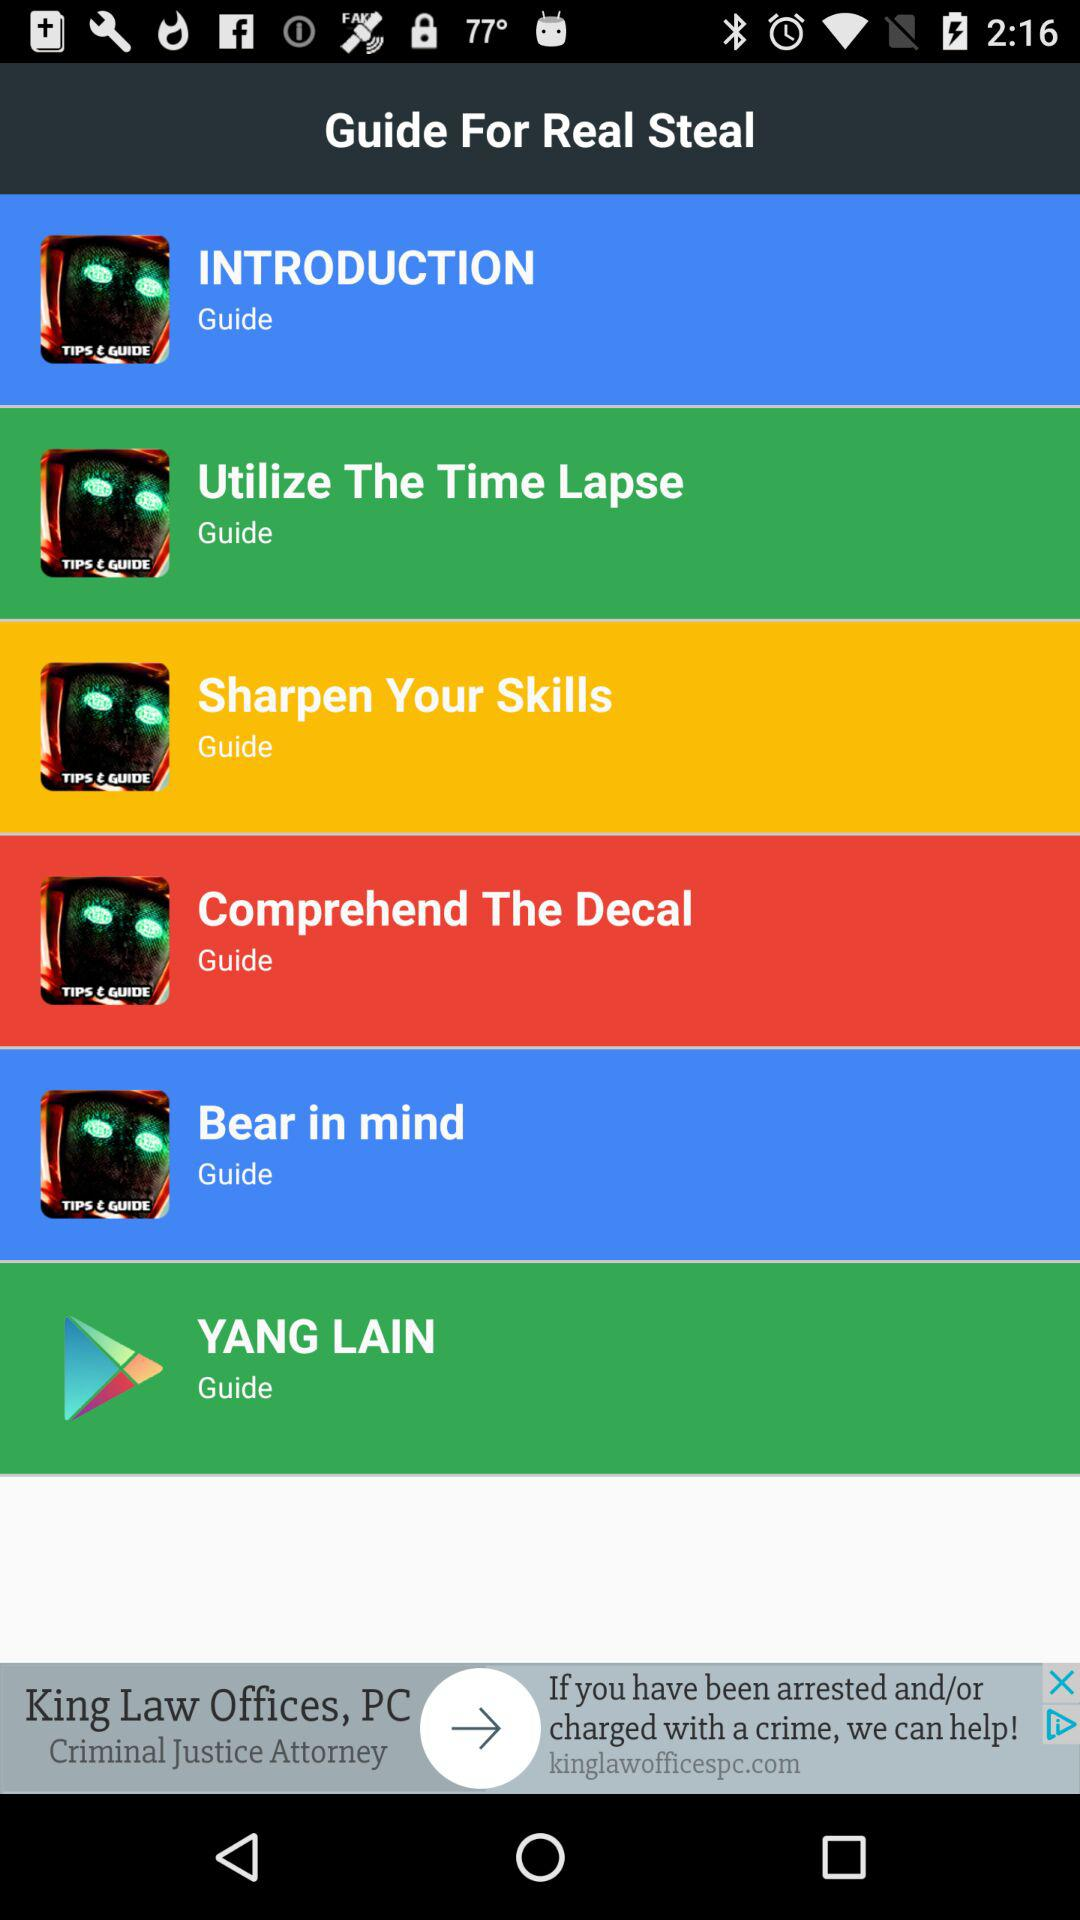What is the application name? The application name is "Guide For Real Steal". 